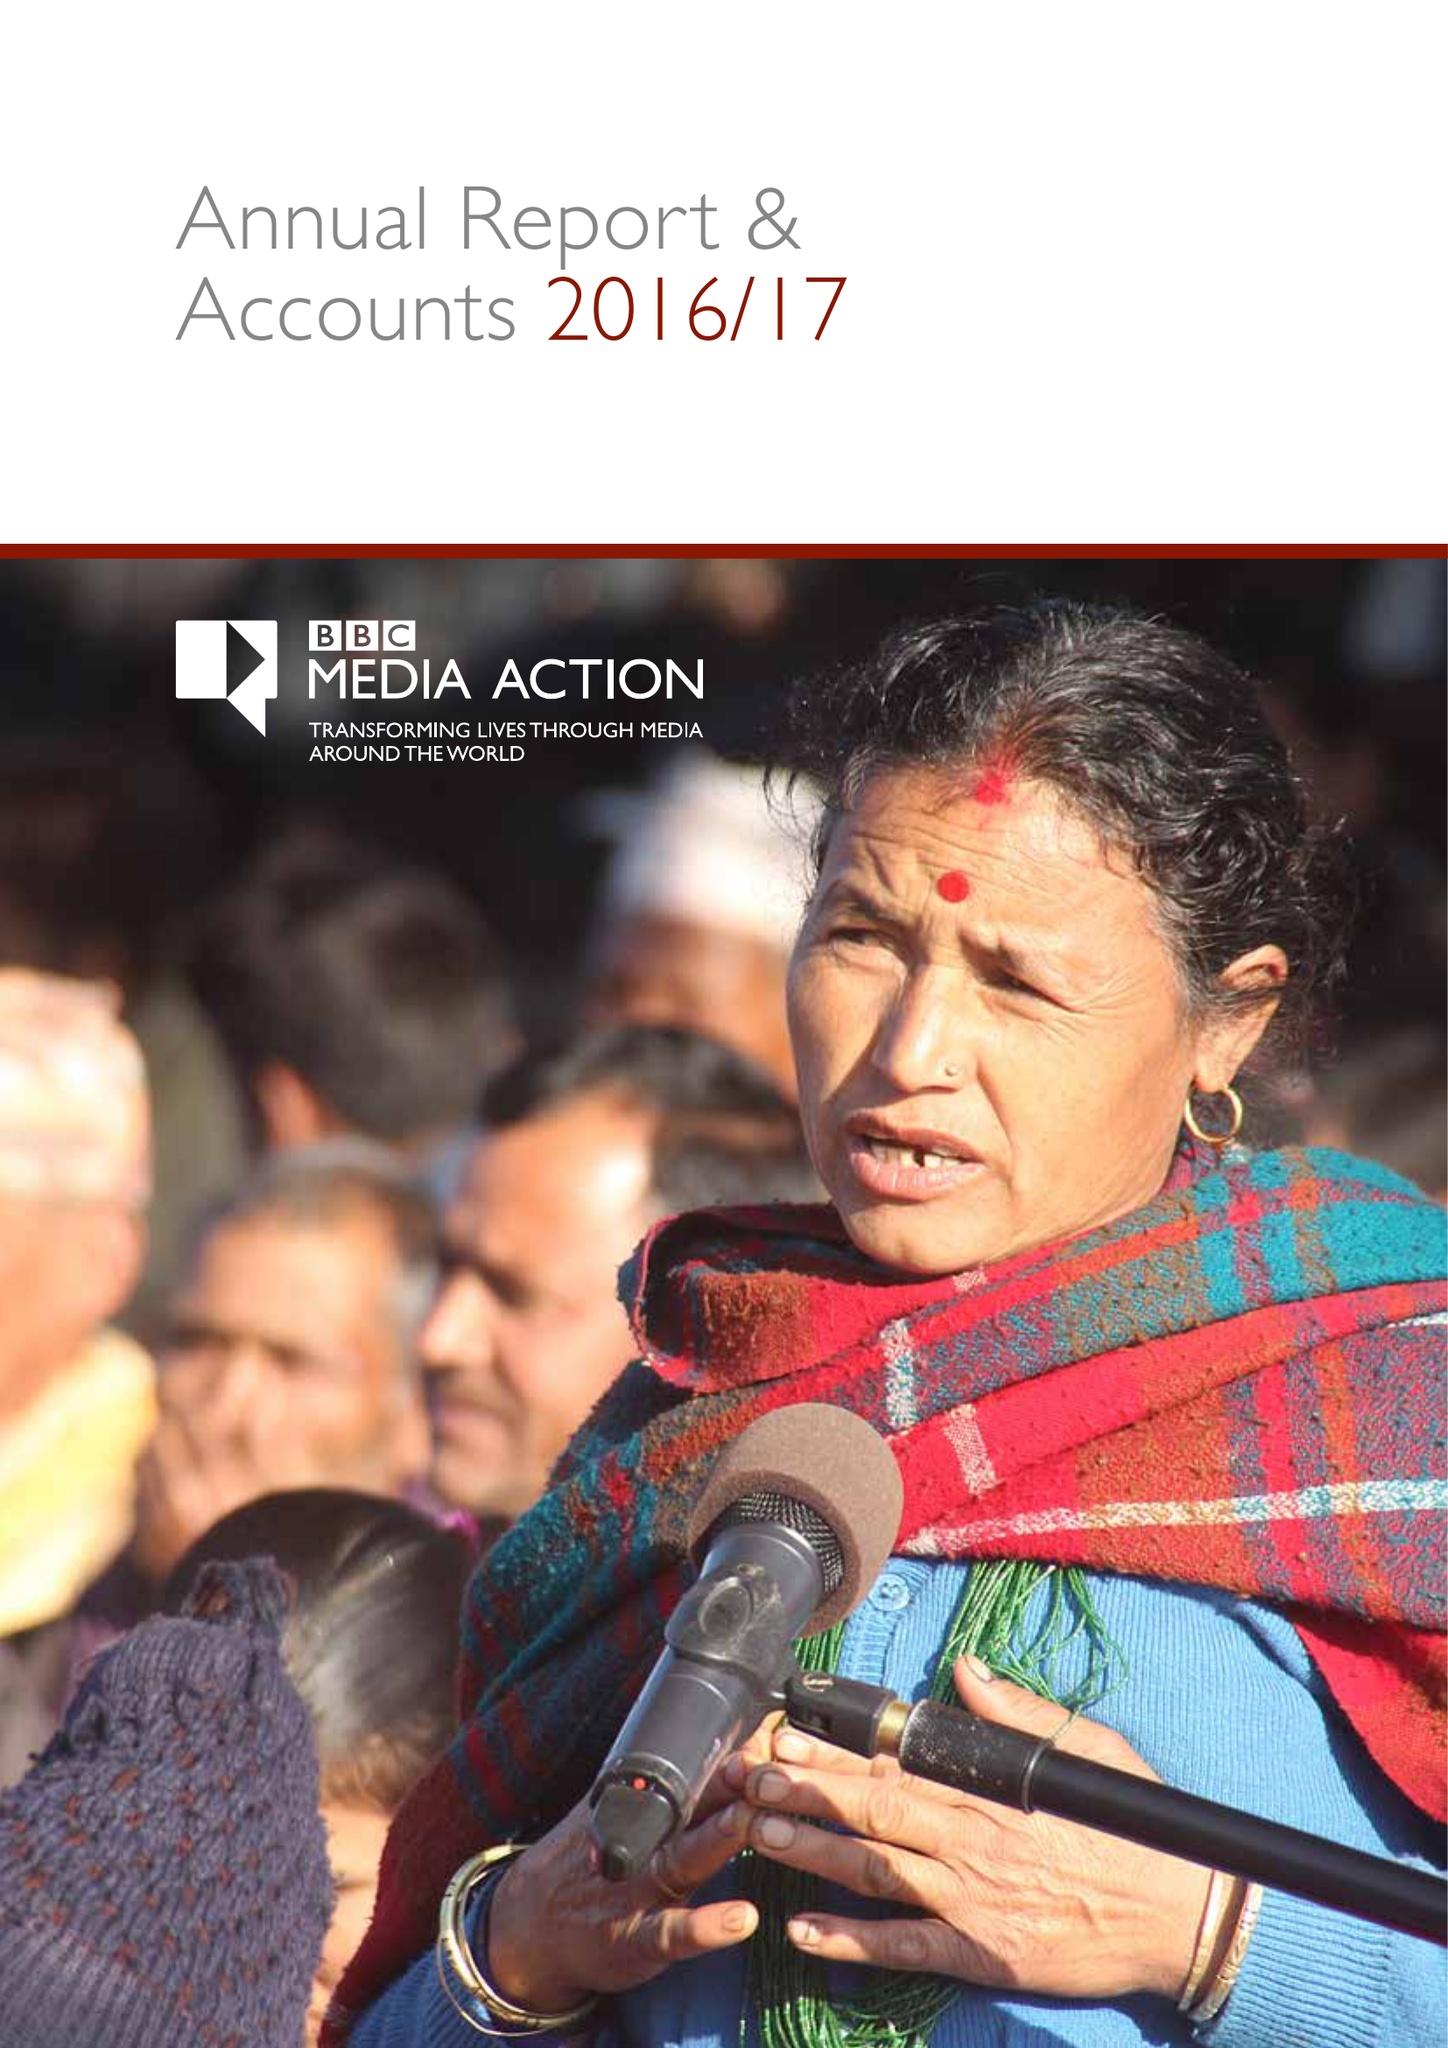What is the value for the address__street_line?
Answer the question using a single word or phrase. PORTLAND PLACE 